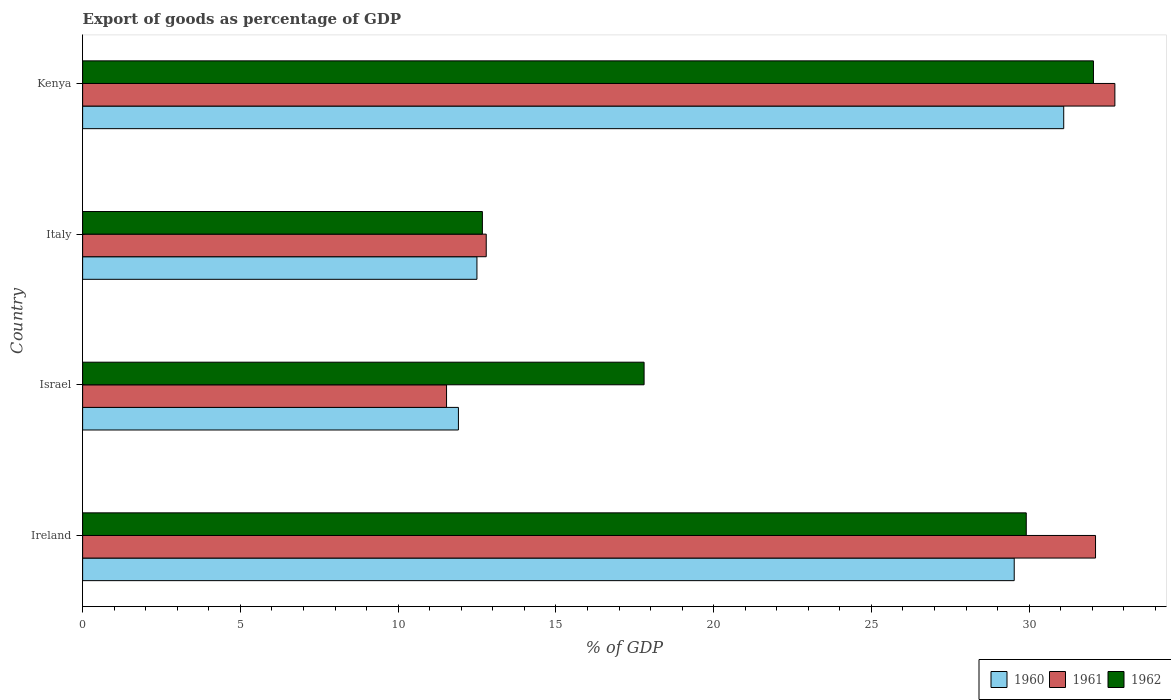How many different coloured bars are there?
Make the answer very short. 3. How many groups of bars are there?
Give a very brief answer. 4. What is the export of goods as percentage of GDP in 1962 in Ireland?
Make the answer very short. 29.91. Across all countries, what is the maximum export of goods as percentage of GDP in 1962?
Your answer should be compact. 32.04. Across all countries, what is the minimum export of goods as percentage of GDP in 1960?
Offer a very short reply. 11.91. In which country was the export of goods as percentage of GDP in 1962 maximum?
Keep it short and to the point. Kenya. In which country was the export of goods as percentage of GDP in 1960 minimum?
Offer a terse response. Israel. What is the total export of goods as percentage of GDP in 1960 in the graph?
Ensure brevity in your answer.  85.03. What is the difference between the export of goods as percentage of GDP in 1962 in Israel and that in Italy?
Your answer should be compact. 5.12. What is the difference between the export of goods as percentage of GDP in 1961 in Ireland and the export of goods as percentage of GDP in 1962 in Kenya?
Provide a succinct answer. 0.07. What is the average export of goods as percentage of GDP in 1962 per country?
Provide a succinct answer. 23.1. What is the difference between the export of goods as percentage of GDP in 1960 and export of goods as percentage of GDP in 1962 in Kenya?
Offer a terse response. -0.94. What is the ratio of the export of goods as percentage of GDP in 1961 in Ireland to that in Italy?
Provide a short and direct response. 2.51. Is the difference between the export of goods as percentage of GDP in 1960 in Ireland and Israel greater than the difference between the export of goods as percentage of GDP in 1962 in Ireland and Israel?
Provide a short and direct response. Yes. What is the difference between the highest and the second highest export of goods as percentage of GDP in 1962?
Keep it short and to the point. 2.13. What is the difference between the highest and the lowest export of goods as percentage of GDP in 1962?
Make the answer very short. 19.37. Is the sum of the export of goods as percentage of GDP in 1961 in Italy and Kenya greater than the maximum export of goods as percentage of GDP in 1960 across all countries?
Offer a very short reply. Yes. Is it the case that in every country, the sum of the export of goods as percentage of GDP in 1962 and export of goods as percentage of GDP in 1960 is greater than the export of goods as percentage of GDP in 1961?
Keep it short and to the point. Yes. Are all the bars in the graph horizontal?
Your answer should be compact. Yes. How many countries are there in the graph?
Ensure brevity in your answer.  4. Does the graph contain any zero values?
Your answer should be compact. No. Does the graph contain grids?
Ensure brevity in your answer.  No. Where does the legend appear in the graph?
Your answer should be very brief. Bottom right. How many legend labels are there?
Offer a very short reply. 3. What is the title of the graph?
Give a very brief answer. Export of goods as percentage of GDP. Does "1964" appear as one of the legend labels in the graph?
Your answer should be very brief. No. What is the label or title of the X-axis?
Keep it short and to the point. % of GDP. What is the label or title of the Y-axis?
Keep it short and to the point. Country. What is the % of GDP in 1960 in Ireland?
Offer a very short reply. 29.53. What is the % of GDP of 1961 in Ireland?
Your response must be concise. 32.1. What is the % of GDP in 1962 in Ireland?
Your answer should be very brief. 29.91. What is the % of GDP of 1960 in Israel?
Provide a succinct answer. 11.91. What is the % of GDP of 1961 in Israel?
Provide a short and direct response. 11.53. What is the % of GDP in 1962 in Israel?
Your answer should be very brief. 17.8. What is the % of GDP of 1960 in Italy?
Your response must be concise. 12.5. What is the % of GDP of 1961 in Italy?
Provide a succinct answer. 12.79. What is the % of GDP of 1962 in Italy?
Give a very brief answer. 12.67. What is the % of GDP in 1960 in Kenya?
Make the answer very short. 31.1. What is the % of GDP of 1961 in Kenya?
Your answer should be very brief. 32.72. What is the % of GDP of 1962 in Kenya?
Provide a succinct answer. 32.04. Across all countries, what is the maximum % of GDP of 1960?
Your answer should be very brief. 31.1. Across all countries, what is the maximum % of GDP of 1961?
Provide a short and direct response. 32.72. Across all countries, what is the maximum % of GDP of 1962?
Give a very brief answer. 32.04. Across all countries, what is the minimum % of GDP in 1960?
Make the answer very short. 11.91. Across all countries, what is the minimum % of GDP of 1961?
Offer a terse response. 11.53. Across all countries, what is the minimum % of GDP of 1962?
Give a very brief answer. 12.67. What is the total % of GDP in 1960 in the graph?
Your answer should be compact. 85.03. What is the total % of GDP in 1961 in the graph?
Offer a very short reply. 89.15. What is the total % of GDP in 1962 in the graph?
Give a very brief answer. 92.41. What is the difference between the % of GDP in 1960 in Ireland and that in Israel?
Keep it short and to the point. 17.62. What is the difference between the % of GDP of 1961 in Ireland and that in Israel?
Your answer should be compact. 20.57. What is the difference between the % of GDP of 1962 in Ireland and that in Israel?
Your answer should be very brief. 12.11. What is the difference between the % of GDP in 1960 in Ireland and that in Italy?
Keep it short and to the point. 17.03. What is the difference between the % of GDP of 1961 in Ireland and that in Italy?
Your answer should be compact. 19.31. What is the difference between the % of GDP of 1962 in Ireland and that in Italy?
Keep it short and to the point. 17.24. What is the difference between the % of GDP of 1960 in Ireland and that in Kenya?
Offer a terse response. -1.57. What is the difference between the % of GDP in 1961 in Ireland and that in Kenya?
Provide a short and direct response. -0.61. What is the difference between the % of GDP in 1962 in Ireland and that in Kenya?
Keep it short and to the point. -2.13. What is the difference between the % of GDP of 1960 in Israel and that in Italy?
Ensure brevity in your answer.  -0.59. What is the difference between the % of GDP in 1961 in Israel and that in Italy?
Give a very brief answer. -1.26. What is the difference between the % of GDP in 1962 in Israel and that in Italy?
Your answer should be compact. 5.12. What is the difference between the % of GDP in 1960 in Israel and that in Kenya?
Provide a short and direct response. -19.18. What is the difference between the % of GDP in 1961 in Israel and that in Kenya?
Your answer should be compact. -21.18. What is the difference between the % of GDP in 1962 in Israel and that in Kenya?
Keep it short and to the point. -14.24. What is the difference between the % of GDP in 1960 in Italy and that in Kenya?
Offer a terse response. -18.6. What is the difference between the % of GDP of 1961 in Italy and that in Kenya?
Provide a succinct answer. -19.92. What is the difference between the % of GDP of 1962 in Italy and that in Kenya?
Keep it short and to the point. -19.37. What is the difference between the % of GDP in 1960 in Ireland and the % of GDP in 1961 in Israel?
Your answer should be compact. 17.99. What is the difference between the % of GDP in 1960 in Ireland and the % of GDP in 1962 in Israel?
Your answer should be very brief. 11.73. What is the difference between the % of GDP in 1961 in Ireland and the % of GDP in 1962 in Israel?
Give a very brief answer. 14.31. What is the difference between the % of GDP in 1960 in Ireland and the % of GDP in 1961 in Italy?
Make the answer very short. 16.73. What is the difference between the % of GDP of 1960 in Ireland and the % of GDP of 1962 in Italy?
Give a very brief answer. 16.86. What is the difference between the % of GDP in 1961 in Ireland and the % of GDP in 1962 in Italy?
Your answer should be very brief. 19.43. What is the difference between the % of GDP in 1960 in Ireland and the % of GDP in 1961 in Kenya?
Ensure brevity in your answer.  -3.19. What is the difference between the % of GDP of 1960 in Ireland and the % of GDP of 1962 in Kenya?
Your answer should be compact. -2.51. What is the difference between the % of GDP of 1961 in Ireland and the % of GDP of 1962 in Kenya?
Provide a succinct answer. 0.07. What is the difference between the % of GDP in 1960 in Israel and the % of GDP in 1961 in Italy?
Offer a very short reply. -0.88. What is the difference between the % of GDP of 1960 in Israel and the % of GDP of 1962 in Italy?
Provide a succinct answer. -0.76. What is the difference between the % of GDP of 1961 in Israel and the % of GDP of 1962 in Italy?
Provide a succinct answer. -1.14. What is the difference between the % of GDP of 1960 in Israel and the % of GDP of 1961 in Kenya?
Ensure brevity in your answer.  -20.81. What is the difference between the % of GDP in 1960 in Israel and the % of GDP in 1962 in Kenya?
Your answer should be very brief. -20.13. What is the difference between the % of GDP of 1961 in Israel and the % of GDP of 1962 in Kenya?
Your response must be concise. -20.5. What is the difference between the % of GDP of 1960 in Italy and the % of GDP of 1961 in Kenya?
Your response must be concise. -20.22. What is the difference between the % of GDP in 1960 in Italy and the % of GDP in 1962 in Kenya?
Your response must be concise. -19.54. What is the difference between the % of GDP in 1961 in Italy and the % of GDP in 1962 in Kenya?
Ensure brevity in your answer.  -19.25. What is the average % of GDP of 1960 per country?
Offer a terse response. 21.26. What is the average % of GDP in 1961 per country?
Your response must be concise. 22.29. What is the average % of GDP in 1962 per country?
Your response must be concise. 23.1. What is the difference between the % of GDP of 1960 and % of GDP of 1961 in Ireland?
Give a very brief answer. -2.58. What is the difference between the % of GDP of 1960 and % of GDP of 1962 in Ireland?
Offer a very short reply. -0.38. What is the difference between the % of GDP of 1961 and % of GDP of 1962 in Ireland?
Provide a succinct answer. 2.2. What is the difference between the % of GDP in 1960 and % of GDP in 1961 in Israel?
Make the answer very short. 0.38. What is the difference between the % of GDP in 1960 and % of GDP in 1962 in Israel?
Offer a terse response. -5.88. What is the difference between the % of GDP of 1961 and % of GDP of 1962 in Israel?
Provide a short and direct response. -6.26. What is the difference between the % of GDP of 1960 and % of GDP of 1961 in Italy?
Your response must be concise. -0.29. What is the difference between the % of GDP of 1960 and % of GDP of 1962 in Italy?
Offer a very short reply. -0.17. What is the difference between the % of GDP of 1961 and % of GDP of 1962 in Italy?
Your answer should be very brief. 0.12. What is the difference between the % of GDP in 1960 and % of GDP in 1961 in Kenya?
Give a very brief answer. -1.62. What is the difference between the % of GDP of 1960 and % of GDP of 1962 in Kenya?
Give a very brief answer. -0.94. What is the difference between the % of GDP in 1961 and % of GDP in 1962 in Kenya?
Keep it short and to the point. 0.68. What is the ratio of the % of GDP of 1960 in Ireland to that in Israel?
Give a very brief answer. 2.48. What is the ratio of the % of GDP in 1961 in Ireland to that in Israel?
Make the answer very short. 2.78. What is the ratio of the % of GDP in 1962 in Ireland to that in Israel?
Offer a very short reply. 1.68. What is the ratio of the % of GDP in 1960 in Ireland to that in Italy?
Your answer should be compact. 2.36. What is the ratio of the % of GDP of 1961 in Ireland to that in Italy?
Give a very brief answer. 2.51. What is the ratio of the % of GDP in 1962 in Ireland to that in Italy?
Provide a short and direct response. 2.36. What is the ratio of the % of GDP in 1960 in Ireland to that in Kenya?
Offer a very short reply. 0.95. What is the ratio of the % of GDP in 1961 in Ireland to that in Kenya?
Keep it short and to the point. 0.98. What is the ratio of the % of GDP in 1962 in Ireland to that in Kenya?
Your answer should be compact. 0.93. What is the ratio of the % of GDP in 1960 in Israel to that in Italy?
Your response must be concise. 0.95. What is the ratio of the % of GDP in 1961 in Israel to that in Italy?
Provide a short and direct response. 0.9. What is the ratio of the % of GDP of 1962 in Israel to that in Italy?
Ensure brevity in your answer.  1.4. What is the ratio of the % of GDP of 1960 in Israel to that in Kenya?
Your answer should be very brief. 0.38. What is the ratio of the % of GDP in 1961 in Israel to that in Kenya?
Provide a succinct answer. 0.35. What is the ratio of the % of GDP of 1962 in Israel to that in Kenya?
Offer a terse response. 0.56. What is the ratio of the % of GDP in 1960 in Italy to that in Kenya?
Offer a terse response. 0.4. What is the ratio of the % of GDP in 1961 in Italy to that in Kenya?
Keep it short and to the point. 0.39. What is the ratio of the % of GDP of 1962 in Italy to that in Kenya?
Your answer should be compact. 0.4. What is the difference between the highest and the second highest % of GDP of 1960?
Ensure brevity in your answer.  1.57. What is the difference between the highest and the second highest % of GDP in 1961?
Keep it short and to the point. 0.61. What is the difference between the highest and the second highest % of GDP in 1962?
Keep it short and to the point. 2.13. What is the difference between the highest and the lowest % of GDP of 1960?
Offer a terse response. 19.18. What is the difference between the highest and the lowest % of GDP in 1961?
Ensure brevity in your answer.  21.18. What is the difference between the highest and the lowest % of GDP in 1962?
Offer a very short reply. 19.37. 